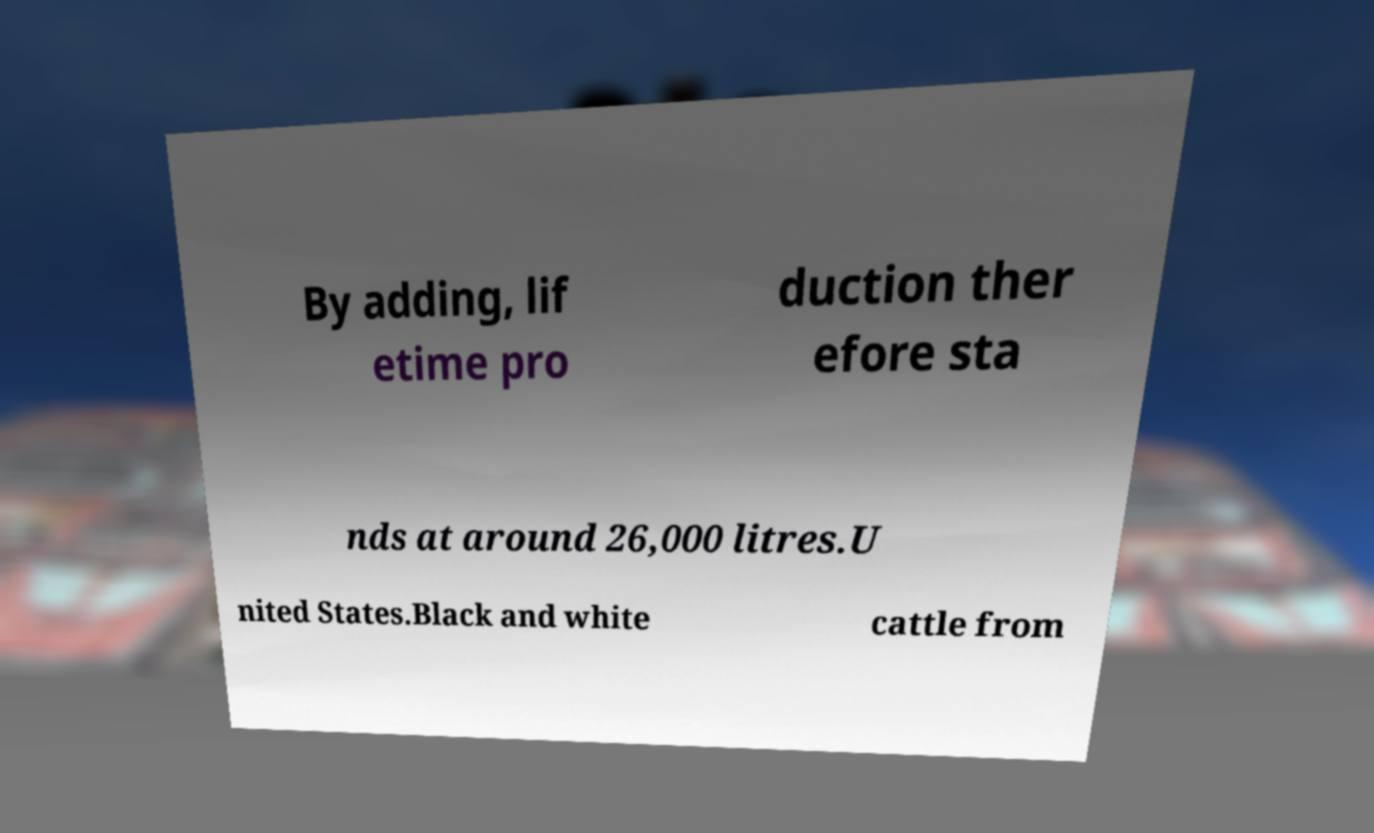For documentation purposes, I need the text within this image transcribed. Could you provide that? By adding, lif etime pro duction ther efore sta nds at around 26,000 litres.U nited States.Black and white cattle from 